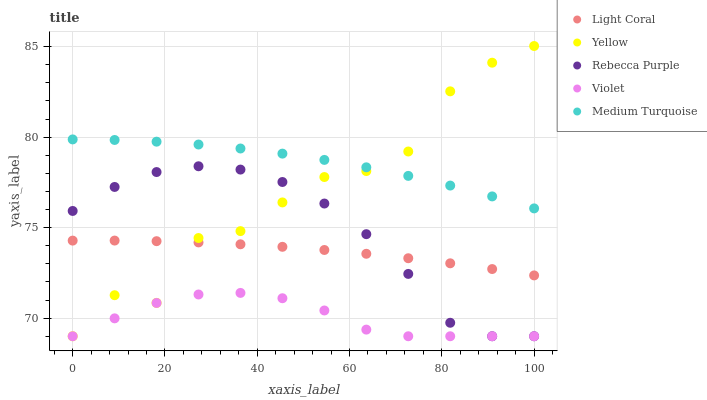Does Violet have the minimum area under the curve?
Answer yes or no. Yes. Does Medium Turquoise have the maximum area under the curve?
Answer yes or no. Yes. Does Rebecca Purple have the minimum area under the curve?
Answer yes or no. No. Does Rebecca Purple have the maximum area under the curve?
Answer yes or no. No. Is Light Coral the smoothest?
Answer yes or no. Yes. Is Yellow the roughest?
Answer yes or no. Yes. Is Medium Turquoise the smoothest?
Answer yes or no. No. Is Medium Turquoise the roughest?
Answer yes or no. No. Does Rebecca Purple have the lowest value?
Answer yes or no. Yes. Does Medium Turquoise have the lowest value?
Answer yes or no. No. Does Yellow have the highest value?
Answer yes or no. Yes. Does Medium Turquoise have the highest value?
Answer yes or no. No. Is Light Coral less than Medium Turquoise?
Answer yes or no. Yes. Is Light Coral greater than Violet?
Answer yes or no. Yes. Does Violet intersect Rebecca Purple?
Answer yes or no. Yes. Is Violet less than Rebecca Purple?
Answer yes or no. No. Is Violet greater than Rebecca Purple?
Answer yes or no. No. Does Light Coral intersect Medium Turquoise?
Answer yes or no. No. 